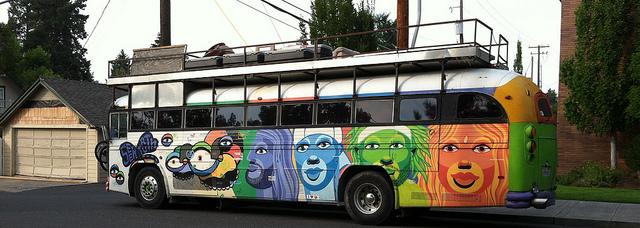Has this bus's artist created a sort of theme with variations?
Short answer required. Yes. What kind of bus is this in the picture?
Quick response, please. Double decker. How many faces are shown on the bus?
Concise answer only. 4. 